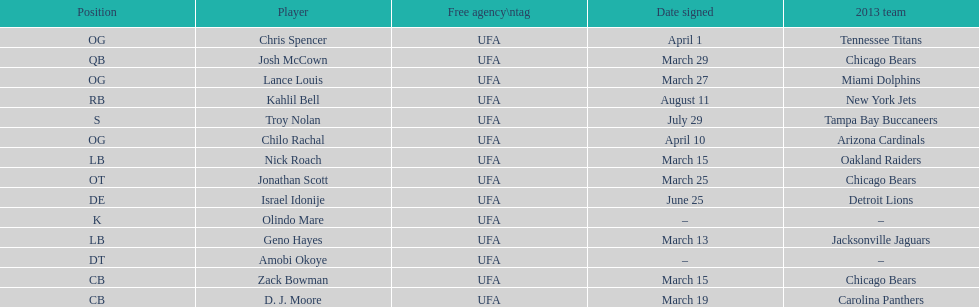The only player to sign in july? Troy Nolan. 